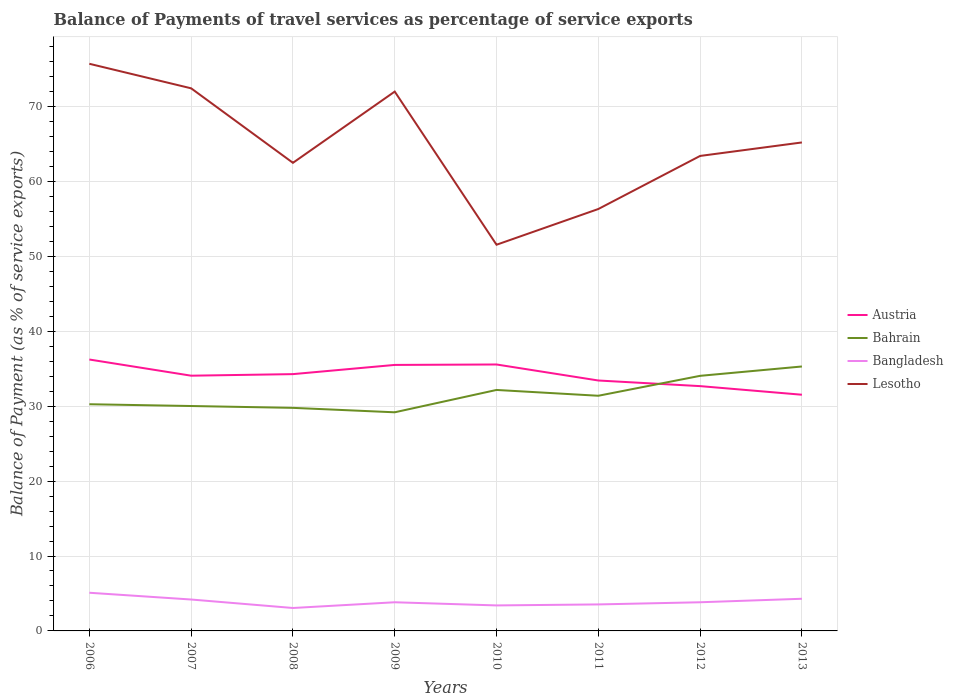Does the line corresponding to Bangladesh intersect with the line corresponding to Austria?
Provide a succinct answer. No. Across all years, what is the maximum balance of payments of travel services in Bangladesh?
Offer a terse response. 3.06. In which year was the balance of payments of travel services in Austria maximum?
Offer a terse response. 2013. What is the total balance of payments of travel services in Austria in the graph?
Your response must be concise. 0.75. What is the difference between the highest and the second highest balance of payments of travel services in Bangladesh?
Make the answer very short. 2.04. Is the balance of payments of travel services in Bahrain strictly greater than the balance of payments of travel services in Austria over the years?
Make the answer very short. No. What is the difference between two consecutive major ticks on the Y-axis?
Ensure brevity in your answer.  10. Does the graph contain any zero values?
Your answer should be compact. No. Where does the legend appear in the graph?
Ensure brevity in your answer.  Center right. How many legend labels are there?
Offer a terse response. 4. What is the title of the graph?
Ensure brevity in your answer.  Balance of Payments of travel services as percentage of service exports. Does "Afghanistan" appear as one of the legend labels in the graph?
Your answer should be compact. No. What is the label or title of the Y-axis?
Your answer should be compact. Balance of Payment (as % of service exports). What is the Balance of Payment (as % of service exports) of Austria in 2006?
Offer a very short reply. 36.23. What is the Balance of Payment (as % of service exports) in Bahrain in 2006?
Your response must be concise. 30.26. What is the Balance of Payment (as % of service exports) in Bangladesh in 2006?
Your answer should be very brief. 5.1. What is the Balance of Payment (as % of service exports) of Lesotho in 2006?
Provide a short and direct response. 75.71. What is the Balance of Payment (as % of service exports) in Austria in 2007?
Provide a short and direct response. 34.07. What is the Balance of Payment (as % of service exports) in Bahrain in 2007?
Make the answer very short. 30.02. What is the Balance of Payment (as % of service exports) in Bangladesh in 2007?
Provide a short and direct response. 4.19. What is the Balance of Payment (as % of service exports) in Lesotho in 2007?
Offer a terse response. 72.43. What is the Balance of Payment (as % of service exports) in Austria in 2008?
Offer a very short reply. 34.28. What is the Balance of Payment (as % of service exports) in Bahrain in 2008?
Give a very brief answer. 29.78. What is the Balance of Payment (as % of service exports) of Bangladesh in 2008?
Your answer should be compact. 3.06. What is the Balance of Payment (as % of service exports) in Lesotho in 2008?
Offer a very short reply. 62.48. What is the Balance of Payment (as % of service exports) of Austria in 2009?
Your answer should be compact. 35.51. What is the Balance of Payment (as % of service exports) in Bahrain in 2009?
Offer a terse response. 29.18. What is the Balance of Payment (as % of service exports) of Bangladesh in 2009?
Provide a succinct answer. 3.83. What is the Balance of Payment (as % of service exports) in Lesotho in 2009?
Give a very brief answer. 71.99. What is the Balance of Payment (as % of service exports) of Austria in 2010?
Offer a terse response. 35.57. What is the Balance of Payment (as % of service exports) of Bahrain in 2010?
Offer a very short reply. 32.17. What is the Balance of Payment (as % of service exports) in Bangladesh in 2010?
Make the answer very short. 3.4. What is the Balance of Payment (as % of service exports) in Lesotho in 2010?
Ensure brevity in your answer.  51.55. What is the Balance of Payment (as % of service exports) of Austria in 2011?
Your answer should be compact. 33.43. What is the Balance of Payment (as % of service exports) in Bahrain in 2011?
Provide a succinct answer. 31.39. What is the Balance of Payment (as % of service exports) in Bangladesh in 2011?
Offer a very short reply. 3.54. What is the Balance of Payment (as % of service exports) in Lesotho in 2011?
Offer a terse response. 56.32. What is the Balance of Payment (as % of service exports) of Austria in 2012?
Your response must be concise. 32.68. What is the Balance of Payment (as % of service exports) in Bahrain in 2012?
Your response must be concise. 34.05. What is the Balance of Payment (as % of service exports) in Bangladesh in 2012?
Your answer should be very brief. 3.83. What is the Balance of Payment (as % of service exports) of Lesotho in 2012?
Your answer should be compact. 63.41. What is the Balance of Payment (as % of service exports) in Austria in 2013?
Make the answer very short. 31.53. What is the Balance of Payment (as % of service exports) of Bahrain in 2013?
Ensure brevity in your answer.  35.3. What is the Balance of Payment (as % of service exports) in Bangladesh in 2013?
Keep it short and to the point. 4.29. What is the Balance of Payment (as % of service exports) of Lesotho in 2013?
Make the answer very short. 65.21. Across all years, what is the maximum Balance of Payment (as % of service exports) in Austria?
Ensure brevity in your answer.  36.23. Across all years, what is the maximum Balance of Payment (as % of service exports) in Bahrain?
Your answer should be compact. 35.3. Across all years, what is the maximum Balance of Payment (as % of service exports) of Bangladesh?
Your answer should be compact. 5.1. Across all years, what is the maximum Balance of Payment (as % of service exports) in Lesotho?
Your response must be concise. 75.71. Across all years, what is the minimum Balance of Payment (as % of service exports) in Austria?
Offer a terse response. 31.53. Across all years, what is the minimum Balance of Payment (as % of service exports) in Bahrain?
Keep it short and to the point. 29.18. Across all years, what is the minimum Balance of Payment (as % of service exports) in Bangladesh?
Ensure brevity in your answer.  3.06. Across all years, what is the minimum Balance of Payment (as % of service exports) of Lesotho?
Provide a succinct answer. 51.55. What is the total Balance of Payment (as % of service exports) of Austria in the graph?
Provide a succinct answer. 273.28. What is the total Balance of Payment (as % of service exports) of Bahrain in the graph?
Offer a terse response. 252.15. What is the total Balance of Payment (as % of service exports) of Bangladesh in the graph?
Provide a short and direct response. 31.23. What is the total Balance of Payment (as % of service exports) of Lesotho in the graph?
Your response must be concise. 519.1. What is the difference between the Balance of Payment (as % of service exports) of Austria in 2006 and that in 2007?
Offer a very short reply. 2.16. What is the difference between the Balance of Payment (as % of service exports) of Bahrain in 2006 and that in 2007?
Ensure brevity in your answer.  0.24. What is the difference between the Balance of Payment (as % of service exports) in Bangladesh in 2006 and that in 2007?
Your answer should be compact. 0.9. What is the difference between the Balance of Payment (as % of service exports) of Lesotho in 2006 and that in 2007?
Offer a terse response. 3.27. What is the difference between the Balance of Payment (as % of service exports) in Austria in 2006 and that in 2008?
Provide a succinct answer. 1.95. What is the difference between the Balance of Payment (as % of service exports) of Bahrain in 2006 and that in 2008?
Keep it short and to the point. 0.48. What is the difference between the Balance of Payment (as % of service exports) of Bangladesh in 2006 and that in 2008?
Provide a short and direct response. 2.04. What is the difference between the Balance of Payment (as % of service exports) in Lesotho in 2006 and that in 2008?
Provide a succinct answer. 13.22. What is the difference between the Balance of Payment (as % of service exports) of Austria in 2006 and that in 2009?
Offer a terse response. 0.72. What is the difference between the Balance of Payment (as % of service exports) of Bahrain in 2006 and that in 2009?
Provide a succinct answer. 1.08. What is the difference between the Balance of Payment (as % of service exports) in Bangladesh in 2006 and that in 2009?
Make the answer very short. 1.27. What is the difference between the Balance of Payment (as % of service exports) in Lesotho in 2006 and that in 2009?
Keep it short and to the point. 3.71. What is the difference between the Balance of Payment (as % of service exports) in Austria in 2006 and that in 2010?
Your answer should be compact. 0.66. What is the difference between the Balance of Payment (as % of service exports) of Bahrain in 2006 and that in 2010?
Offer a very short reply. -1.91. What is the difference between the Balance of Payment (as % of service exports) of Bangladesh in 2006 and that in 2010?
Offer a very short reply. 1.69. What is the difference between the Balance of Payment (as % of service exports) in Lesotho in 2006 and that in 2010?
Provide a succinct answer. 24.15. What is the difference between the Balance of Payment (as % of service exports) of Austria in 2006 and that in 2011?
Your answer should be very brief. 2.8. What is the difference between the Balance of Payment (as % of service exports) of Bahrain in 2006 and that in 2011?
Your answer should be very brief. -1.13. What is the difference between the Balance of Payment (as % of service exports) of Bangladesh in 2006 and that in 2011?
Give a very brief answer. 1.56. What is the difference between the Balance of Payment (as % of service exports) in Lesotho in 2006 and that in 2011?
Keep it short and to the point. 19.39. What is the difference between the Balance of Payment (as % of service exports) of Austria in 2006 and that in 2012?
Offer a very short reply. 3.55. What is the difference between the Balance of Payment (as % of service exports) of Bahrain in 2006 and that in 2012?
Provide a short and direct response. -3.79. What is the difference between the Balance of Payment (as % of service exports) in Bangladesh in 2006 and that in 2012?
Provide a succinct answer. 1.27. What is the difference between the Balance of Payment (as % of service exports) of Lesotho in 2006 and that in 2012?
Give a very brief answer. 12.3. What is the difference between the Balance of Payment (as % of service exports) in Austria in 2006 and that in 2013?
Your response must be concise. 4.7. What is the difference between the Balance of Payment (as % of service exports) of Bahrain in 2006 and that in 2013?
Ensure brevity in your answer.  -5.04. What is the difference between the Balance of Payment (as % of service exports) in Bangladesh in 2006 and that in 2013?
Provide a succinct answer. 0.8. What is the difference between the Balance of Payment (as % of service exports) of Lesotho in 2006 and that in 2013?
Ensure brevity in your answer.  10.5. What is the difference between the Balance of Payment (as % of service exports) of Austria in 2007 and that in 2008?
Your answer should be compact. -0.21. What is the difference between the Balance of Payment (as % of service exports) of Bahrain in 2007 and that in 2008?
Provide a succinct answer. 0.25. What is the difference between the Balance of Payment (as % of service exports) in Bangladesh in 2007 and that in 2008?
Ensure brevity in your answer.  1.13. What is the difference between the Balance of Payment (as % of service exports) in Lesotho in 2007 and that in 2008?
Your answer should be compact. 9.95. What is the difference between the Balance of Payment (as % of service exports) in Austria in 2007 and that in 2009?
Your response must be concise. -1.44. What is the difference between the Balance of Payment (as % of service exports) in Bahrain in 2007 and that in 2009?
Give a very brief answer. 0.84. What is the difference between the Balance of Payment (as % of service exports) of Bangladesh in 2007 and that in 2009?
Provide a short and direct response. 0.37. What is the difference between the Balance of Payment (as % of service exports) of Lesotho in 2007 and that in 2009?
Offer a very short reply. 0.44. What is the difference between the Balance of Payment (as % of service exports) of Austria in 2007 and that in 2010?
Provide a succinct answer. -1.5. What is the difference between the Balance of Payment (as % of service exports) of Bahrain in 2007 and that in 2010?
Ensure brevity in your answer.  -2.15. What is the difference between the Balance of Payment (as % of service exports) in Bangladesh in 2007 and that in 2010?
Your response must be concise. 0.79. What is the difference between the Balance of Payment (as % of service exports) in Lesotho in 2007 and that in 2010?
Ensure brevity in your answer.  20.88. What is the difference between the Balance of Payment (as % of service exports) of Austria in 2007 and that in 2011?
Keep it short and to the point. 0.64. What is the difference between the Balance of Payment (as % of service exports) in Bahrain in 2007 and that in 2011?
Ensure brevity in your answer.  -1.37. What is the difference between the Balance of Payment (as % of service exports) in Bangladesh in 2007 and that in 2011?
Make the answer very short. 0.66. What is the difference between the Balance of Payment (as % of service exports) in Lesotho in 2007 and that in 2011?
Your answer should be very brief. 16.11. What is the difference between the Balance of Payment (as % of service exports) in Austria in 2007 and that in 2012?
Keep it short and to the point. 1.39. What is the difference between the Balance of Payment (as % of service exports) of Bahrain in 2007 and that in 2012?
Offer a very short reply. -4.03. What is the difference between the Balance of Payment (as % of service exports) of Bangladesh in 2007 and that in 2012?
Your response must be concise. 0.37. What is the difference between the Balance of Payment (as % of service exports) of Lesotho in 2007 and that in 2012?
Offer a terse response. 9.03. What is the difference between the Balance of Payment (as % of service exports) in Austria in 2007 and that in 2013?
Ensure brevity in your answer.  2.54. What is the difference between the Balance of Payment (as % of service exports) in Bahrain in 2007 and that in 2013?
Your answer should be very brief. -5.28. What is the difference between the Balance of Payment (as % of service exports) in Bangladesh in 2007 and that in 2013?
Give a very brief answer. -0.1. What is the difference between the Balance of Payment (as % of service exports) of Lesotho in 2007 and that in 2013?
Your answer should be very brief. 7.23. What is the difference between the Balance of Payment (as % of service exports) of Austria in 2008 and that in 2009?
Ensure brevity in your answer.  -1.23. What is the difference between the Balance of Payment (as % of service exports) of Bahrain in 2008 and that in 2009?
Keep it short and to the point. 0.59. What is the difference between the Balance of Payment (as % of service exports) in Bangladesh in 2008 and that in 2009?
Offer a very short reply. -0.77. What is the difference between the Balance of Payment (as % of service exports) in Lesotho in 2008 and that in 2009?
Provide a short and direct response. -9.51. What is the difference between the Balance of Payment (as % of service exports) of Austria in 2008 and that in 2010?
Your answer should be very brief. -1.29. What is the difference between the Balance of Payment (as % of service exports) of Bahrain in 2008 and that in 2010?
Your answer should be compact. -2.39. What is the difference between the Balance of Payment (as % of service exports) of Bangladesh in 2008 and that in 2010?
Your answer should be very brief. -0.34. What is the difference between the Balance of Payment (as % of service exports) in Lesotho in 2008 and that in 2010?
Provide a succinct answer. 10.93. What is the difference between the Balance of Payment (as % of service exports) of Austria in 2008 and that in 2011?
Keep it short and to the point. 0.85. What is the difference between the Balance of Payment (as % of service exports) in Bahrain in 2008 and that in 2011?
Ensure brevity in your answer.  -1.61. What is the difference between the Balance of Payment (as % of service exports) of Bangladesh in 2008 and that in 2011?
Keep it short and to the point. -0.48. What is the difference between the Balance of Payment (as % of service exports) in Lesotho in 2008 and that in 2011?
Offer a terse response. 6.16. What is the difference between the Balance of Payment (as % of service exports) in Austria in 2008 and that in 2012?
Offer a very short reply. 1.6. What is the difference between the Balance of Payment (as % of service exports) of Bahrain in 2008 and that in 2012?
Ensure brevity in your answer.  -4.28. What is the difference between the Balance of Payment (as % of service exports) of Bangladesh in 2008 and that in 2012?
Ensure brevity in your answer.  -0.77. What is the difference between the Balance of Payment (as % of service exports) in Lesotho in 2008 and that in 2012?
Your answer should be compact. -0.92. What is the difference between the Balance of Payment (as % of service exports) in Austria in 2008 and that in 2013?
Keep it short and to the point. 2.75. What is the difference between the Balance of Payment (as % of service exports) of Bahrain in 2008 and that in 2013?
Your answer should be very brief. -5.52. What is the difference between the Balance of Payment (as % of service exports) of Bangladesh in 2008 and that in 2013?
Offer a very short reply. -1.23. What is the difference between the Balance of Payment (as % of service exports) of Lesotho in 2008 and that in 2013?
Your response must be concise. -2.72. What is the difference between the Balance of Payment (as % of service exports) of Austria in 2009 and that in 2010?
Provide a succinct answer. -0.06. What is the difference between the Balance of Payment (as % of service exports) of Bahrain in 2009 and that in 2010?
Your response must be concise. -2.98. What is the difference between the Balance of Payment (as % of service exports) of Bangladesh in 2009 and that in 2010?
Keep it short and to the point. 0.42. What is the difference between the Balance of Payment (as % of service exports) of Lesotho in 2009 and that in 2010?
Your answer should be very brief. 20.44. What is the difference between the Balance of Payment (as % of service exports) of Austria in 2009 and that in 2011?
Make the answer very short. 2.08. What is the difference between the Balance of Payment (as % of service exports) of Bahrain in 2009 and that in 2011?
Provide a succinct answer. -2.21. What is the difference between the Balance of Payment (as % of service exports) in Bangladesh in 2009 and that in 2011?
Your response must be concise. 0.29. What is the difference between the Balance of Payment (as % of service exports) of Lesotho in 2009 and that in 2011?
Your answer should be very brief. 15.67. What is the difference between the Balance of Payment (as % of service exports) of Austria in 2009 and that in 2012?
Provide a short and direct response. 2.83. What is the difference between the Balance of Payment (as % of service exports) in Bahrain in 2009 and that in 2012?
Offer a very short reply. -4.87. What is the difference between the Balance of Payment (as % of service exports) in Bangladesh in 2009 and that in 2012?
Make the answer very short. -0. What is the difference between the Balance of Payment (as % of service exports) of Lesotho in 2009 and that in 2012?
Provide a succinct answer. 8.59. What is the difference between the Balance of Payment (as % of service exports) in Austria in 2009 and that in 2013?
Give a very brief answer. 3.98. What is the difference between the Balance of Payment (as % of service exports) in Bahrain in 2009 and that in 2013?
Provide a short and direct response. -6.11. What is the difference between the Balance of Payment (as % of service exports) in Bangladesh in 2009 and that in 2013?
Your response must be concise. -0.47. What is the difference between the Balance of Payment (as % of service exports) in Lesotho in 2009 and that in 2013?
Make the answer very short. 6.79. What is the difference between the Balance of Payment (as % of service exports) of Austria in 2010 and that in 2011?
Make the answer very short. 2.14. What is the difference between the Balance of Payment (as % of service exports) of Bahrain in 2010 and that in 2011?
Offer a very short reply. 0.78. What is the difference between the Balance of Payment (as % of service exports) in Bangladesh in 2010 and that in 2011?
Your answer should be very brief. -0.13. What is the difference between the Balance of Payment (as % of service exports) of Lesotho in 2010 and that in 2011?
Offer a terse response. -4.77. What is the difference between the Balance of Payment (as % of service exports) of Austria in 2010 and that in 2012?
Provide a succinct answer. 2.89. What is the difference between the Balance of Payment (as % of service exports) of Bahrain in 2010 and that in 2012?
Offer a terse response. -1.88. What is the difference between the Balance of Payment (as % of service exports) in Bangladesh in 2010 and that in 2012?
Keep it short and to the point. -0.42. What is the difference between the Balance of Payment (as % of service exports) in Lesotho in 2010 and that in 2012?
Make the answer very short. -11.85. What is the difference between the Balance of Payment (as % of service exports) in Austria in 2010 and that in 2013?
Provide a short and direct response. 4.04. What is the difference between the Balance of Payment (as % of service exports) of Bahrain in 2010 and that in 2013?
Make the answer very short. -3.13. What is the difference between the Balance of Payment (as % of service exports) in Bangladesh in 2010 and that in 2013?
Offer a very short reply. -0.89. What is the difference between the Balance of Payment (as % of service exports) in Lesotho in 2010 and that in 2013?
Make the answer very short. -13.65. What is the difference between the Balance of Payment (as % of service exports) of Austria in 2011 and that in 2012?
Offer a terse response. 0.75. What is the difference between the Balance of Payment (as % of service exports) in Bahrain in 2011 and that in 2012?
Give a very brief answer. -2.66. What is the difference between the Balance of Payment (as % of service exports) of Bangladesh in 2011 and that in 2012?
Ensure brevity in your answer.  -0.29. What is the difference between the Balance of Payment (as % of service exports) in Lesotho in 2011 and that in 2012?
Your answer should be compact. -7.08. What is the difference between the Balance of Payment (as % of service exports) of Austria in 2011 and that in 2013?
Your answer should be very brief. 1.9. What is the difference between the Balance of Payment (as % of service exports) of Bahrain in 2011 and that in 2013?
Make the answer very short. -3.91. What is the difference between the Balance of Payment (as % of service exports) of Bangladesh in 2011 and that in 2013?
Ensure brevity in your answer.  -0.75. What is the difference between the Balance of Payment (as % of service exports) in Lesotho in 2011 and that in 2013?
Make the answer very short. -8.88. What is the difference between the Balance of Payment (as % of service exports) in Austria in 2012 and that in 2013?
Your answer should be very brief. 1.15. What is the difference between the Balance of Payment (as % of service exports) of Bahrain in 2012 and that in 2013?
Provide a short and direct response. -1.25. What is the difference between the Balance of Payment (as % of service exports) of Bangladesh in 2012 and that in 2013?
Provide a succinct answer. -0.47. What is the difference between the Balance of Payment (as % of service exports) in Lesotho in 2012 and that in 2013?
Offer a terse response. -1.8. What is the difference between the Balance of Payment (as % of service exports) in Austria in 2006 and the Balance of Payment (as % of service exports) in Bahrain in 2007?
Your answer should be very brief. 6.21. What is the difference between the Balance of Payment (as % of service exports) of Austria in 2006 and the Balance of Payment (as % of service exports) of Bangladesh in 2007?
Offer a terse response. 32.04. What is the difference between the Balance of Payment (as % of service exports) of Austria in 2006 and the Balance of Payment (as % of service exports) of Lesotho in 2007?
Your answer should be very brief. -36.2. What is the difference between the Balance of Payment (as % of service exports) in Bahrain in 2006 and the Balance of Payment (as % of service exports) in Bangladesh in 2007?
Provide a succinct answer. 26.07. What is the difference between the Balance of Payment (as % of service exports) of Bahrain in 2006 and the Balance of Payment (as % of service exports) of Lesotho in 2007?
Provide a short and direct response. -42.17. What is the difference between the Balance of Payment (as % of service exports) of Bangladesh in 2006 and the Balance of Payment (as % of service exports) of Lesotho in 2007?
Offer a very short reply. -67.34. What is the difference between the Balance of Payment (as % of service exports) in Austria in 2006 and the Balance of Payment (as % of service exports) in Bahrain in 2008?
Your answer should be very brief. 6.45. What is the difference between the Balance of Payment (as % of service exports) in Austria in 2006 and the Balance of Payment (as % of service exports) in Bangladesh in 2008?
Make the answer very short. 33.17. What is the difference between the Balance of Payment (as % of service exports) of Austria in 2006 and the Balance of Payment (as % of service exports) of Lesotho in 2008?
Give a very brief answer. -26.26. What is the difference between the Balance of Payment (as % of service exports) in Bahrain in 2006 and the Balance of Payment (as % of service exports) in Bangladesh in 2008?
Offer a terse response. 27.2. What is the difference between the Balance of Payment (as % of service exports) in Bahrain in 2006 and the Balance of Payment (as % of service exports) in Lesotho in 2008?
Your response must be concise. -32.22. What is the difference between the Balance of Payment (as % of service exports) in Bangladesh in 2006 and the Balance of Payment (as % of service exports) in Lesotho in 2008?
Offer a very short reply. -57.39. What is the difference between the Balance of Payment (as % of service exports) in Austria in 2006 and the Balance of Payment (as % of service exports) in Bahrain in 2009?
Your answer should be compact. 7.05. What is the difference between the Balance of Payment (as % of service exports) in Austria in 2006 and the Balance of Payment (as % of service exports) in Bangladesh in 2009?
Keep it short and to the point. 32.4. What is the difference between the Balance of Payment (as % of service exports) in Austria in 2006 and the Balance of Payment (as % of service exports) in Lesotho in 2009?
Your response must be concise. -35.77. What is the difference between the Balance of Payment (as % of service exports) of Bahrain in 2006 and the Balance of Payment (as % of service exports) of Bangladesh in 2009?
Provide a short and direct response. 26.43. What is the difference between the Balance of Payment (as % of service exports) in Bahrain in 2006 and the Balance of Payment (as % of service exports) in Lesotho in 2009?
Offer a very short reply. -41.73. What is the difference between the Balance of Payment (as % of service exports) in Bangladesh in 2006 and the Balance of Payment (as % of service exports) in Lesotho in 2009?
Offer a very short reply. -66.9. What is the difference between the Balance of Payment (as % of service exports) in Austria in 2006 and the Balance of Payment (as % of service exports) in Bahrain in 2010?
Give a very brief answer. 4.06. What is the difference between the Balance of Payment (as % of service exports) of Austria in 2006 and the Balance of Payment (as % of service exports) of Bangladesh in 2010?
Keep it short and to the point. 32.82. What is the difference between the Balance of Payment (as % of service exports) in Austria in 2006 and the Balance of Payment (as % of service exports) in Lesotho in 2010?
Offer a very short reply. -15.32. What is the difference between the Balance of Payment (as % of service exports) in Bahrain in 2006 and the Balance of Payment (as % of service exports) in Bangladesh in 2010?
Provide a short and direct response. 26.86. What is the difference between the Balance of Payment (as % of service exports) in Bahrain in 2006 and the Balance of Payment (as % of service exports) in Lesotho in 2010?
Make the answer very short. -21.29. What is the difference between the Balance of Payment (as % of service exports) in Bangladesh in 2006 and the Balance of Payment (as % of service exports) in Lesotho in 2010?
Offer a terse response. -46.46. What is the difference between the Balance of Payment (as % of service exports) of Austria in 2006 and the Balance of Payment (as % of service exports) of Bahrain in 2011?
Provide a succinct answer. 4.84. What is the difference between the Balance of Payment (as % of service exports) in Austria in 2006 and the Balance of Payment (as % of service exports) in Bangladesh in 2011?
Offer a terse response. 32.69. What is the difference between the Balance of Payment (as % of service exports) in Austria in 2006 and the Balance of Payment (as % of service exports) in Lesotho in 2011?
Your answer should be very brief. -20.09. What is the difference between the Balance of Payment (as % of service exports) of Bahrain in 2006 and the Balance of Payment (as % of service exports) of Bangladesh in 2011?
Give a very brief answer. 26.72. What is the difference between the Balance of Payment (as % of service exports) in Bahrain in 2006 and the Balance of Payment (as % of service exports) in Lesotho in 2011?
Provide a short and direct response. -26.06. What is the difference between the Balance of Payment (as % of service exports) of Bangladesh in 2006 and the Balance of Payment (as % of service exports) of Lesotho in 2011?
Offer a terse response. -51.22. What is the difference between the Balance of Payment (as % of service exports) in Austria in 2006 and the Balance of Payment (as % of service exports) in Bahrain in 2012?
Provide a succinct answer. 2.18. What is the difference between the Balance of Payment (as % of service exports) of Austria in 2006 and the Balance of Payment (as % of service exports) of Bangladesh in 2012?
Your answer should be very brief. 32.4. What is the difference between the Balance of Payment (as % of service exports) of Austria in 2006 and the Balance of Payment (as % of service exports) of Lesotho in 2012?
Give a very brief answer. -27.18. What is the difference between the Balance of Payment (as % of service exports) in Bahrain in 2006 and the Balance of Payment (as % of service exports) in Bangladesh in 2012?
Your response must be concise. 26.43. What is the difference between the Balance of Payment (as % of service exports) in Bahrain in 2006 and the Balance of Payment (as % of service exports) in Lesotho in 2012?
Your answer should be very brief. -33.15. What is the difference between the Balance of Payment (as % of service exports) of Bangladesh in 2006 and the Balance of Payment (as % of service exports) of Lesotho in 2012?
Make the answer very short. -58.31. What is the difference between the Balance of Payment (as % of service exports) in Austria in 2006 and the Balance of Payment (as % of service exports) in Bahrain in 2013?
Make the answer very short. 0.93. What is the difference between the Balance of Payment (as % of service exports) in Austria in 2006 and the Balance of Payment (as % of service exports) in Bangladesh in 2013?
Your answer should be compact. 31.94. What is the difference between the Balance of Payment (as % of service exports) of Austria in 2006 and the Balance of Payment (as % of service exports) of Lesotho in 2013?
Offer a terse response. -28.98. What is the difference between the Balance of Payment (as % of service exports) in Bahrain in 2006 and the Balance of Payment (as % of service exports) in Bangladesh in 2013?
Your answer should be compact. 25.97. What is the difference between the Balance of Payment (as % of service exports) in Bahrain in 2006 and the Balance of Payment (as % of service exports) in Lesotho in 2013?
Provide a succinct answer. -34.94. What is the difference between the Balance of Payment (as % of service exports) of Bangladesh in 2006 and the Balance of Payment (as % of service exports) of Lesotho in 2013?
Your answer should be very brief. -60.11. What is the difference between the Balance of Payment (as % of service exports) of Austria in 2007 and the Balance of Payment (as % of service exports) of Bahrain in 2008?
Provide a succinct answer. 4.29. What is the difference between the Balance of Payment (as % of service exports) in Austria in 2007 and the Balance of Payment (as % of service exports) in Bangladesh in 2008?
Offer a very short reply. 31.01. What is the difference between the Balance of Payment (as % of service exports) of Austria in 2007 and the Balance of Payment (as % of service exports) of Lesotho in 2008?
Provide a succinct answer. -28.41. What is the difference between the Balance of Payment (as % of service exports) of Bahrain in 2007 and the Balance of Payment (as % of service exports) of Bangladesh in 2008?
Offer a terse response. 26.96. What is the difference between the Balance of Payment (as % of service exports) of Bahrain in 2007 and the Balance of Payment (as % of service exports) of Lesotho in 2008?
Give a very brief answer. -32.46. What is the difference between the Balance of Payment (as % of service exports) of Bangladesh in 2007 and the Balance of Payment (as % of service exports) of Lesotho in 2008?
Your answer should be compact. -58.29. What is the difference between the Balance of Payment (as % of service exports) of Austria in 2007 and the Balance of Payment (as % of service exports) of Bahrain in 2009?
Ensure brevity in your answer.  4.89. What is the difference between the Balance of Payment (as % of service exports) in Austria in 2007 and the Balance of Payment (as % of service exports) in Bangladesh in 2009?
Keep it short and to the point. 30.24. What is the difference between the Balance of Payment (as % of service exports) of Austria in 2007 and the Balance of Payment (as % of service exports) of Lesotho in 2009?
Your answer should be compact. -37.92. What is the difference between the Balance of Payment (as % of service exports) in Bahrain in 2007 and the Balance of Payment (as % of service exports) in Bangladesh in 2009?
Give a very brief answer. 26.2. What is the difference between the Balance of Payment (as % of service exports) of Bahrain in 2007 and the Balance of Payment (as % of service exports) of Lesotho in 2009?
Offer a very short reply. -41.97. What is the difference between the Balance of Payment (as % of service exports) in Bangladesh in 2007 and the Balance of Payment (as % of service exports) in Lesotho in 2009?
Offer a very short reply. -67.8. What is the difference between the Balance of Payment (as % of service exports) in Austria in 2007 and the Balance of Payment (as % of service exports) in Bahrain in 2010?
Ensure brevity in your answer.  1.9. What is the difference between the Balance of Payment (as % of service exports) of Austria in 2007 and the Balance of Payment (as % of service exports) of Bangladesh in 2010?
Make the answer very short. 30.67. What is the difference between the Balance of Payment (as % of service exports) in Austria in 2007 and the Balance of Payment (as % of service exports) in Lesotho in 2010?
Offer a very short reply. -17.48. What is the difference between the Balance of Payment (as % of service exports) of Bahrain in 2007 and the Balance of Payment (as % of service exports) of Bangladesh in 2010?
Provide a succinct answer. 26.62. What is the difference between the Balance of Payment (as % of service exports) of Bahrain in 2007 and the Balance of Payment (as % of service exports) of Lesotho in 2010?
Make the answer very short. -21.53. What is the difference between the Balance of Payment (as % of service exports) in Bangladesh in 2007 and the Balance of Payment (as % of service exports) in Lesotho in 2010?
Make the answer very short. -47.36. What is the difference between the Balance of Payment (as % of service exports) of Austria in 2007 and the Balance of Payment (as % of service exports) of Bahrain in 2011?
Your response must be concise. 2.68. What is the difference between the Balance of Payment (as % of service exports) of Austria in 2007 and the Balance of Payment (as % of service exports) of Bangladesh in 2011?
Offer a very short reply. 30.53. What is the difference between the Balance of Payment (as % of service exports) in Austria in 2007 and the Balance of Payment (as % of service exports) in Lesotho in 2011?
Your answer should be very brief. -22.25. What is the difference between the Balance of Payment (as % of service exports) in Bahrain in 2007 and the Balance of Payment (as % of service exports) in Bangladesh in 2011?
Ensure brevity in your answer.  26.48. What is the difference between the Balance of Payment (as % of service exports) of Bahrain in 2007 and the Balance of Payment (as % of service exports) of Lesotho in 2011?
Give a very brief answer. -26.3. What is the difference between the Balance of Payment (as % of service exports) in Bangladesh in 2007 and the Balance of Payment (as % of service exports) in Lesotho in 2011?
Offer a terse response. -52.13. What is the difference between the Balance of Payment (as % of service exports) of Austria in 2007 and the Balance of Payment (as % of service exports) of Bahrain in 2012?
Your response must be concise. 0.02. What is the difference between the Balance of Payment (as % of service exports) of Austria in 2007 and the Balance of Payment (as % of service exports) of Bangladesh in 2012?
Ensure brevity in your answer.  30.24. What is the difference between the Balance of Payment (as % of service exports) of Austria in 2007 and the Balance of Payment (as % of service exports) of Lesotho in 2012?
Offer a terse response. -29.34. What is the difference between the Balance of Payment (as % of service exports) in Bahrain in 2007 and the Balance of Payment (as % of service exports) in Bangladesh in 2012?
Ensure brevity in your answer.  26.2. What is the difference between the Balance of Payment (as % of service exports) in Bahrain in 2007 and the Balance of Payment (as % of service exports) in Lesotho in 2012?
Ensure brevity in your answer.  -33.38. What is the difference between the Balance of Payment (as % of service exports) in Bangladesh in 2007 and the Balance of Payment (as % of service exports) in Lesotho in 2012?
Your answer should be very brief. -59.21. What is the difference between the Balance of Payment (as % of service exports) in Austria in 2007 and the Balance of Payment (as % of service exports) in Bahrain in 2013?
Offer a very short reply. -1.23. What is the difference between the Balance of Payment (as % of service exports) in Austria in 2007 and the Balance of Payment (as % of service exports) in Bangladesh in 2013?
Offer a very short reply. 29.78. What is the difference between the Balance of Payment (as % of service exports) in Austria in 2007 and the Balance of Payment (as % of service exports) in Lesotho in 2013?
Provide a succinct answer. -31.14. What is the difference between the Balance of Payment (as % of service exports) of Bahrain in 2007 and the Balance of Payment (as % of service exports) of Bangladesh in 2013?
Ensure brevity in your answer.  25.73. What is the difference between the Balance of Payment (as % of service exports) of Bahrain in 2007 and the Balance of Payment (as % of service exports) of Lesotho in 2013?
Offer a very short reply. -35.18. What is the difference between the Balance of Payment (as % of service exports) of Bangladesh in 2007 and the Balance of Payment (as % of service exports) of Lesotho in 2013?
Your answer should be very brief. -61.01. What is the difference between the Balance of Payment (as % of service exports) of Austria in 2008 and the Balance of Payment (as % of service exports) of Bahrain in 2009?
Make the answer very short. 5.09. What is the difference between the Balance of Payment (as % of service exports) in Austria in 2008 and the Balance of Payment (as % of service exports) in Bangladesh in 2009?
Provide a short and direct response. 30.45. What is the difference between the Balance of Payment (as % of service exports) of Austria in 2008 and the Balance of Payment (as % of service exports) of Lesotho in 2009?
Your response must be concise. -37.72. What is the difference between the Balance of Payment (as % of service exports) of Bahrain in 2008 and the Balance of Payment (as % of service exports) of Bangladesh in 2009?
Keep it short and to the point. 25.95. What is the difference between the Balance of Payment (as % of service exports) of Bahrain in 2008 and the Balance of Payment (as % of service exports) of Lesotho in 2009?
Provide a short and direct response. -42.22. What is the difference between the Balance of Payment (as % of service exports) in Bangladesh in 2008 and the Balance of Payment (as % of service exports) in Lesotho in 2009?
Offer a very short reply. -68.93. What is the difference between the Balance of Payment (as % of service exports) in Austria in 2008 and the Balance of Payment (as % of service exports) in Bahrain in 2010?
Your response must be concise. 2.11. What is the difference between the Balance of Payment (as % of service exports) in Austria in 2008 and the Balance of Payment (as % of service exports) in Bangladesh in 2010?
Your answer should be very brief. 30.87. What is the difference between the Balance of Payment (as % of service exports) of Austria in 2008 and the Balance of Payment (as % of service exports) of Lesotho in 2010?
Offer a very short reply. -17.27. What is the difference between the Balance of Payment (as % of service exports) in Bahrain in 2008 and the Balance of Payment (as % of service exports) in Bangladesh in 2010?
Provide a succinct answer. 26.37. What is the difference between the Balance of Payment (as % of service exports) in Bahrain in 2008 and the Balance of Payment (as % of service exports) in Lesotho in 2010?
Give a very brief answer. -21.77. What is the difference between the Balance of Payment (as % of service exports) of Bangladesh in 2008 and the Balance of Payment (as % of service exports) of Lesotho in 2010?
Provide a short and direct response. -48.49. What is the difference between the Balance of Payment (as % of service exports) in Austria in 2008 and the Balance of Payment (as % of service exports) in Bahrain in 2011?
Provide a short and direct response. 2.89. What is the difference between the Balance of Payment (as % of service exports) in Austria in 2008 and the Balance of Payment (as % of service exports) in Bangladesh in 2011?
Your answer should be compact. 30.74. What is the difference between the Balance of Payment (as % of service exports) of Austria in 2008 and the Balance of Payment (as % of service exports) of Lesotho in 2011?
Give a very brief answer. -22.04. What is the difference between the Balance of Payment (as % of service exports) of Bahrain in 2008 and the Balance of Payment (as % of service exports) of Bangladesh in 2011?
Your answer should be very brief. 26.24. What is the difference between the Balance of Payment (as % of service exports) of Bahrain in 2008 and the Balance of Payment (as % of service exports) of Lesotho in 2011?
Keep it short and to the point. -26.54. What is the difference between the Balance of Payment (as % of service exports) of Bangladesh in 2008 and the Balance of Payment (as % of service exports) of Lesotho in 2011?
Provide a succinct answer. -53.26. What is the difference between the Balance of Payment (as % of service exports) of Austria in 2008 and the Balance of Payment (as % of service exports) of Bahrain in 2012?
Offer a terse response. 0.23. What is the difference between the Balance of Payment (as % of service exports) in Austria in 2008 and the Balance of Payment (as % of service exports) in Bangladesh in 2012?
Keep it short and to the point. 30.45. What is the difference between the Balance of Payment (as % of service exports) of Austria in 2008 and the Balance of Payment (as % of service exports) of Lesotho in 2012?
Provide a short and direct response. -29.13. What is the difference between the Balance of Payment (as % of service exports) in Bahrain in 2008 and the Balance of Payment (as % of service exports) in Bangladesh in 2012?
Offer a terse response. 25.95. What is the difference between the Balance of Payment (as % of service exports) of Bahrain in 2008 and the Balance of Payment (as % of service exports) of Lesotho in 2012?
Provide a succinct answer. -33.63. What is the difference between the Balance of Payment (as % of service exports) of Bangladesh in 2008 and the Balance of Payment (as % of service exports) of Lesotho in 2012?
Offer a terse response. -60.34. What is the difference between the Balance of Payment (as % of service exports) in Austria in 2008 and the Balance of Payment (as % of service exports) in Bahrain in 2013?
Provide a short and direct response. -1.02. What is the difference between the Balance of Payment (as % of service exports) in Austria in 2008 and the Balance of Payment (as % of service exports) in Bangladesh in 2013?
Give a very brief answer. 29.99. What is the difference between the Balance of Payment (as % of service exports) in Austria in 2008 and the Balance of Payment (as % of service exports) in Lesotho in 2013?
Your response must be concise. -30.93. What is the difference between the Balance of Payment (as % of service exports) of Bahrain in 2008 and the Balance of Payment (as % of service exports) of Bangladesh in 2013?
Provide a succinct answer. 25.49. What is the difference between the Balance of Payment (as % of service exports) in Bahrain in 2008 and the Balance of Payment (as % of service exports) in Lesotho in 2013?
Make the answer very short. -35.43. What is the difference between the Balance of Payment (as % of service exports) in Bangladesh in 2008 and the Balance of Payment (as % of service exports) in Lesotho in 2013?
Ensure brevity in your answer.  -62.14. What is the difference between the Balance of Payment (as % of service exports) in Austria in 2009 and the Balance of Payment (as % of service exports) in Bahrain in 2010?
Give a very brief answer. 3.34. What is the difference between the Balance of Payment (as % of service exports) of Austria in 2009 and the Balance of Payment (as % of service exports) of Bangladesh in 2010?
Offer a terse response. 32.1. What is the difference between the Balance of Payment (as % of service exports) of Austria in 2009 and the Balance of Payment (as % of service exports) of Lesotho in 2010?
Offer a terse response. -16.04. What is the difference between the Balance of Payment (as % of service exports) of Bahrain in 2009 and the Balance of Payment (as % of service exports) of Bangladesh in 2010?
Keep it short and to the point. 25.78. What is the difference between the Balance of Payment (as % of service exports) in Bahrain in 2009 and the Balance of Payment (as % of service exports) in Lesotho in 2010?
Your answer should be compact. -22.37. What is the difference between the Balance of Payment (as % of service exports) in Bangladesh in 2009 and the Balance of Payment (as % of service exports) in Lesotho in 2010?
Ensure brevity in your answer.  -47.73. What is the difference between the Balance of Payment (as % of service exports) of Austria in 2009 and the Balance of Payment (as % of service exports) of Bahrain in 2011?
Offer a terse response. 4.12. What is the difference between the Balance of Payment (as % of service exports) of Austria in 2009 and the Balance of Payment (as % of service exports) of Bangladesh in 2011?
Your answer should be compact. 31.97. What is the difference between the Balance of Payment (as % of service exports) of Austria in 2009 and the Balance of Payment (as % of service exports) of Lesotho in 2011?
Keep it short and to the point. -20.81. What is the difference between the Balance of Payment (as % of service exports) in Bahrain in 2009 and the Balance of Payment (as % of service exports) in Bangladesh in 2011?
Provide a succinct answer. 25.65. What is the difference between the Balance of Payment (as % of service exports) in Bahrain in 2009 and the Balance of Payment (as % of service exports) in Lesotho in 2011?
Your answer should be very brief. -27.14. What is the difference between the Balance of Payment (as % of service exports) in Bangladesh in 2009 and the Balance of Payment (as % of service exports) in Lesotho in 2011?
Your response must be concise. -52.49. What is the difference between the Balance of Payment (as % of service exports) in Austria in 2009 and the Balance of Payment (as % of service exports) in Bahrain in 2012?
Provide a short and direct response. 1.46. What is the difference between the Balance of Payment (as % of service exports) in Austria in 2009 and the Balance of Payment (as % of service exports) in Bangladesh in 2012?
Your answer should be very brief. 31.68. What is the difference between the Balance of Payment (as % of service exports) in Austria in 2009 and the Balance of Payment (as % of service exports) in Lesotho in 2012?
Make the answer very short. -27.9. What is the difference between the Balance of Payment (as % of service exports) in Bahrain in 2009 and the Balance of Payment (as % of service exports) in Bangladesh in 2012?
Ensure brevity in your answer.  25.36. What is the difference between the Balance of Payment (as % of service exports) of Bahrain in 2009 and the Balance of Payment (as % of service exports) of Lesotho in 2012?
Keep it short and to the point. -34.22. What is the difference between the Balance of Payment (as % of service exports) in Bangladesh in 2009 and the Balance of Payment (as % of service exports) in Lesotho in 2012?
Offer a terse response. -59.58. What is the difference between the Balance of Payment (as % of service exports) in Austria in 2009 and the Balance of Payment (as % of service exports) in Bahrain in 2013?
Offer a terse response. 0.21. What is the difference between the Balance of Payment (as % of service exports) of Austria in 2009 and the Balance of Payment (as % of service exports) of Bangladesh in 2013?
Offer a terse response. 31.22. What is the difference between the Balance of Payment (as % of service exports) in Austria in 2009 and the Balance of Payment (as % of service exports) in Lesotho in 2013?
Your answer should be very brief. -29.7. What is the difference between the Balance of Payment (as % of service exports) in Bahrain in 2009 and the Balance of Payment (as % of service exports) in Bangladesh in 2013?
Make the answer very short. 24.89. What is the difference between the Balance of Payment (as % of service exports) in Bahrain in 2009 and the Balance of Payment (as % of service exports) in Lesotho in 2013?
Offer a very short reply. -36.02. What is the difference between the Balance of Payment (as % of service exports) of Bangladesh in 2009 and the Balance of Payment (as % of service exports) of Lesotho in 2013?
Give a very brief answer. -61.38. What is the difference between the Balance of Payment (as % of service exports) of Austria in 2010 and the Balance of Payment (as % of service exports) of Bahrain in 2011?
Your response must be concise. 4.17. What is the difference between the Balance of Payment (as % of service exports) in Austria in 2010 and the Balance of Payment (as % of service exports) in Bangladesh in 2011?
Offer a very short reply. 32.03. What is the difference between the Balance of Payment (as % of service exports) in Austria in 2010 and the Balance of Payment (as % of service exports) in Lesotho in 2011?
Your answer should be compact. -20.75. What is the difference between the Balance of Payment (as % of service exports) in Bahrain in 2010 and the Balance of Payment (as % of service exports) in Bangladesh in 2011?
Keep it short and to the point. 28.63. What is the difference between the Balance of Payment (as % of service exports) of Bahrain in 2010 and the Balance of Payment (as % of service exports) of Lesotho in 2011?
Make the answer very short. -24.15. What is the difference between the Balance of Payment (as % of service exports) in Bangladesh in 2010 and the Balance of Payment (as % of service exports) in Lesotho in 2011?
Provide a succinct answer. -52.92. What is the difference between the Balance of Payment (as % of service exports) in Austria in 2010 and the Balance of Payment (as % of service exports) in Bahrain in 2012?
Your answer should be compact. 1.51. What is the difference between the Balance of Payment (as % of service exports) of Austria in 2010 and the Balance of Payment (as % of service exports) of Bangladesh in 2012?
Your answer should be very brief. 31.74. What is the difference between the Balance of Payment (as % of service exports) of Austria in 2010 and the Balance of Payment (as % of service exports) of Lesotho in 2012?
Your response must be concise. -27.84. What is the difference between the Balance of Payment (as % of service exports) of Bahrain in 2010 and the Balance of Payment (as % of service exports) of Bangladesh in 2012?
Ensure brevity in your answer.  28.34. What is the difference between the Balance of Payment (as % of service exports) in Bahrain in 2010 and the Balance of Payment (as % of service exports) in Lesotho in 2012?
Make the answer very short. -31.24. What is the difference between the Balance of Payment (as % of service exports) in Bangladesh in 2010 and the Balance of Payment (as % of service exports) in Lesotho in 2012?
Provide a short and direct response. -60. What is the difference between the Balance of Payment (as % of service exports) in Austria in 2010 and the Balance of Payment (as % of service exports) in Bahrain in 2013?
Offer a very short reply. 0.27. What is the difference between the Balance of Payment (as % of service exports) of Austria in 2010 and the Balance of Payment (as % of service exports) of Bangladesh in 2013?
Provide a succinct answer. 31.27. What is the difference between the Balance of Payment (as % of service exports) of Austria in 2010 and the Balance of Payment (as % of service exports) of Lesotho in 2013?
Your response must be concise. -29.64. What is the difference between the Balance of Payment (as % of service exports) of Bahrain in 2010 and the Balance of Payment (as % of service exports) of Bangladesh in 2013?
Provide a short and direct response. 27.88. What is the difference between the Balance of Payment (as % of service exports) of Bahrain in 2010 and the Balance of Payment (as % of service exports) of Lesotho in 2013?
Provide a succinct answer. -33.04. What is the difference between the Balance of Payment (as % of service exports) in Bangladesh in 2010 and the Balance of Payment (as % of service exports) in Lesotho in 2013?
Provide a succinct answer. -61.8. What is the difference between the Balance of Payment (as % of service exports) in Austria in 2011 and the Balance of Payment (as % of service exports) in Bahrain in 2012?
Your response must be concise. -0.62. What is the difference between the Balance of Payment (as % of service exports) in Austria in 2011 and the Balance of Payment (as % of service exports) in Bangladesh in 2012?
Give a very brief answer. 29.6. What is the difference between the Balance of Payment (as % of service exports) in Austria in 2011 and the Balance of Payment (as % of service exports) in Lesotho in 2012?
Your response must be concise. -29.98. What is the difference between the Balance of Payment (as % of service exports) of Bahrain in 2011 and the Balance of Payment (as % of service exports) of Bangladesh in 2012?
Your answer should be compact. 27.57. What is the difference between the Balance of Payment (as % of service exports) of Bahrain in 2011 and the Balance of Payment (as % of service exports) of Lesotho in 2012?
Your answer should be compact. -32.01. What is the difference between the Balance of Payment (as % of service exports) of Bangladesh in 2011 and the Balance of Payment (as % of service exports) of Lesotho in 2012?
Ensure brevity in your answer.  -59.87. What is the difference between the Balance of Payment (as % of service exports) in Austria in 2011 and the Balance of Payment (as % of service exports) in Bahrain in 2013?
Ensure brevity in your answer.  -1.87. What is the difference between the Balance of Payment (as % of service exports) in Austria in 2011 and the Balance of Payment (as % of service exports) in Bangladesh in 2013?
Ensure brevity in your answer.  29.14. What is the difference between the Balance of Payment (as % of service exports) in Austria in 2011 and the Balance of Payment (as % of service exports) in Lesotho in 2013?
Provide a succinct answer. -31.78. What is the difference between the Balance of Payment (as % of service exports) of Bahrain in 2011 and the Balance of Payment (as % of service exports) of Bangladesh in 2013?
Ensure brevity in your answer.  27.1. What is the difference between the Balance of Payment (as % of service exports) of Bahrain in 2011 and the Balance of Payment (as % of service exports) of Lesotho in 2013?
Offer a very short reply. -33.81. What is the difference between the Balance of Payment (as % of service exports) in Bangladesh in 2011 and the Balance of Payment (as % of service exports) in Lesotho in 2013?
Provide a succinct answer. -61.67. What is the difference between the Balance of Payment (as % of service exports) of Austria in 2012 and the Balance of Payment (as % of service exports) of Bahrain in 2013?
Make the answer very short. -2.62. What is the difference between the Balance of Payment (as % of service exports) of Austria in 2012 and the Balance of Payment (as % of service exports) of Bangladesh in 2013?
Offer a terse response. 28.39. What is the difference between the Balance of Payment (as % of service exports) in Austria in 2012 and the Balance of Payment (as % of service exports) in Lesotho in 2013?
Provide a succinct answer. -32.53. What is the difference between the Balance of Payment (as % of service exports) of Bahrain in 2012 and the Balance of Payment (as % of service exports) of Bangladesh in 2013?
Keep it short and to the point. 29.76. What is the difference between the Balance of Payment (as % of service exports) of Bahrain in 2012 and the Balance of Payment (as % of service exports) of Lesotho in 2013?
Make the answer very short. -31.15. What is the difference between the Balance of Payment (as % of service exports) of Bangladesh in 2012 and the Balance of Payment (as % of service exports) of Lesotho in 2013?
Your response must be concise. -61.38. What is the average Balance of Payment (as % of service exports) of Austria per year?
Make the answer very short. 34.16. What is the average Balance of Payment (as % of service exports) of Bahrain per year?
Give a very brief answer. 31.52. What is the average Balance of Payment (as % of service exports) in Bangladesh per year?
Offer a terse response. 3.9. What is the average Balance of Payment (as % of service exports) of Lesotho per year?
Provide a short and direct response. 64.89. In the year 2006, what is the difference between the Balance of Payment (as % of service exports) of Austria and Balance of Payment (as % of service exports) of Bahrain?
Provide a succinct answer. 5.97. In the year 2006, what is the difference between the Balance of Payment (as % of service exports) in Austria and Balance of Payment (as % of service exports) in Bangladesh?
Give a very brief answer. 31.13. In the year 2006, what is the difference between the Balance of Payment (as % of service exports) in Austria and Balance of Payment (as % of service exports) in Lesotho?
Your answer should be compact. -39.48. In the year 2006, what is the difference between the Balance of Payment (as % of service exports) in Bahrain and Balance of Payment (as % of service exports) in Bangladesh?
Your answer should be very brief. 25.16. In the year 2006, what is the difference between the Balance of Payment (as % of service exports) in Bahrain and Balance of Payment (as % of service exports) in Lesotho?
Your answer should be compact. -45.44. In the year 2006, what is the difference between the Balance of Payment (as % of service exports) in Bangladesh and Balance of Payment (as % of service exports) in Lesotho?
Give a very brief answer. -70.61. In the year 2007, what is the difference between the Balance of Payment (as % of service exports) of Austria and Balance of Payment (as % of service exports) of Bahrain?
Make the answer very short. 4.05. In the year 2007, what is the difference between the Balance of Payment (as % of service exports) of Austria and Balance of Payment (as % of service exports) of Bangladesh?
Provide a succinct answer. 29.88. In the year 2007, what is the difference between the Balance of Payment (as % of service exports) of Austria and Balance of Payment (as % of service exports) of Lesotho?
Offer a very short reply. -38.36. In the year 2007, what is the difference between the Balance of Payment (as % of service exports) of Bahrain and Balance of Payment (as % of service exports) of Bangladesh?
Offer a very short reply. 25.83. In the year 2007, what is the difference between the Balance of Payment (as % of service exports) in Bahrain and Balance of Payment (as % of service exports) in Lesotho?
Your response must be concise. -42.41. In the year 2007, what is the difference between the Balance of Payment (as % of service exports) in Bangladesh and Balance of Payment (as % of service exports) in Lesotho?
Give a very brief answer. -68.24. In the year 2008, what is the difference between the Balance of Payment (as % of service exports) in Austria and Balance of Payment (as % of service exports) in Bahrain?
Make the answer very short. 4.5. In the year 2008, what is the difference between the Balance of Payment (as % of service exports) of Austria and Balance of Payment (as % of service exports) of Bangladesh?
Your answer should be very brief. 31.22. In the year 2008, what is the difference between the Balance of Payment (as % of service exports) in Austria and Balance of Payment (as % of service exports) in Lesotho?
Your response must be concise. -28.21. In the year 2008, what is the difference between the Balance of Payment (as % of service exports) of Bahrain and Balance of Payment (as % of service exports) of Bangladesh?
Keep it short and to the point. 26.72. In the year 2008, what is the difference between the Balance of Payment (as % of service exports) in Bahrain and Balance of Payment (as % of service exports) in Lesotho?
Offer a very short reply. -32.71. In the year 2008, what is the difference between the Balance of Payment (as % of service exports) in Bangladesh and Balance of Payment (as % of service exports) in Lesotho?
Keep it short and to the point. -59.42. In the year 2009, what is the difference between the Balance of Payment (as % of service exports) of Austria and Balance of Payment (as % of service exports) of Bahrain?
Ensure brevity in your answer.  6.32. In the year 2009, what is the difference between the Balance of Payment (as % of service exports) of Austria and Balance of Payment (as % of service exports) of Bangladesh?
Provide a succinct answer. 31.68. In the year 2009, what is the difference between the Balance of Payment (as % of service exports) of Austria and Balance of Payment (as % of service exports) of Lesotho?
Give a very brief answer. -36.49. In the year 2009, what is the difference between the Balance of Payment (as % of service exports) in Bahrain and Balance of Payment (as % of service exports) in Bangladesh?
Provide a short and direct response. 25.36. In the year 2009, what is the difference between the Balance of Payment (as % of service exports) in Bahrain and Balance of Payment (as % of service exports) in Lesotho?
Your answer should be compact. -42.81. In the year 2009, what is the difference between the Balance of Payment (as % of service exports) in Bangladesh and Balance of Payment (as % of service exports) in Lesotho?
Give a very brief answer. -68.17. In the year 2010, what is the difference between the Balance of Payment (as % of service exports) in Austria and Balance of Payment (as % of service exports) in Bahrain?
Give a very brief answer. 3.4. In the year 2010, what is the difference between the Balance of Payment (as % of service exports) of Austria and Balance of Payment (as % of service exports) of Bangladesh?
Keep it short and to the point. 32.16. In the year 2010, what is the difference between the Balance of Payment (as % of service exports) in Austria and Balance of Payment (as % of service exports) in Lesotho?
Your answer should be very brief. -15.99. In the year 2010, what is the difference between the Balance of Payment (as % of service exports) of Bahrain and Balance of Payment (as % of service exports) of Bangladesh?
Your response must be concise. 28.76. In the year 2010, what is the difference between the Balance of Payment (as % of service exports) of Bahrain and Balance of Payment (as % of service exports) of Lesotho?
Offer a very short reply. -19.38. In the year 2010, what is the difference between the Balance of Payment (as % of service exports) in Bangladesh and Balance of Payment (as % of service exports) in Lesotho?
Provide a succinct answer. -48.15. In the year 2011, what is the difference between the Balance of Payment (as % of service exports) in Austria and Balance of Payment (as % of service exports) in Bahrain?
Ensure brevity in your answer.  2.04. In the year 2011, what is the difference between the Balance of Payment (as % of service exports) in Austria and Balance of Payment (as % of service exports) in Bangladesh?
Offer a very short reply. 29.89. In the year 2011, what is the difference between the Balance of Payment (as % of service exports) in Austria and Balance of Payment (as % of service exports) in Lesotho?
Provide a succinct answer. -22.89. In the year 2011, what is the difference between the Balance of Payment (as % of service exports) of Bahrain and Balance of Payment (as % of service exports) of Bangladesh?
Provide a short and direct response. 27.85. In the year 2011, what is the difference between the Balance of Payment (as % of service exports) in Bahrain and Balance of Payment (as % of service exports) in Lesotho?
Your answer should be very brief. -24.93. In the year 2011, what is the difference between the Balance of Payment (as % of service exports) in Bangladesh and Balance of Payment (as % of service exports) in Lesotho?
Your response must be concise. -52.78. In the year 2012, what is the difference between the Balance of Payment (as % of service exports) of Austria and Balance of Payment (as % of service exports) of Bahrain?
Keep it short and to the point. -1.37. In the year 2012, what is the difference between the Balance of Payment (as % of service exports) of Austria and Balance of Payment (as % of service exports) of Bangladesh?
Ensure brevity in your answer.  28.85. In the year 2012, what is the difference between the Balance of Payment (as % of service exports) in Austria and Balance of Payment (as % of service exports) in Lesotho?
Keep it short and to the point. -30.73. In the year 2012, what is the difference between the Balance of Payment (as % of service exports) in Bahrain and Balance of Payment (as % of service exports) in Bangladesh?
Your answer should be compact. 30.23. In the year 2012, what is the difference between the Balance of Payment (as % of service exports) of Bahrain and Balance of Payment (as % of service exports) of Lesotho?
Make the answer very short. -29.35. In the year 2012, what is the difference between the Balance of Payment (as % of service exports) in Bangladesh and Balance of Payment (as % of service exports) in Lesotho?
Your response must be concise. -59.58. In the year 2013, what is the difference between the Balance of Payment (as % of service exports) in Austria and Balance of Payment (as % of service exports) in Bahrain?
Keep it short and to the point. -3.77. In the year 2013, what is the difference between the Balance of Payment (as % of service exports) of Austria and Balance of Payment (as % of service exports) of Bangladesh?
Your answer should be very brief. 27.24. In the year 2013, what is the difference between the Balance of Payment (as % of service exports) in Austria and Balance of Payment (as % of service exports) in Lesotho?
Make the answer very short. -33.68. In the year 2013, what is the difference between the Balance of Payment (as % of service exports) in Bahrain and Balance of Payment (as % of service exports) in Bangladesh?
Provide a succinct answer. 31.01. In the year 2013, what is the difference between the Balance of Payment (as % of service exports) in Bahrain and Balance of Payment (as % of service exports) in Lesotho?
Your answer should be very brief. -29.91. In the year 2013, what is the difference between the Balance of Payment (as % of service exports) of Bangladesh and Balance of Payment (as % of service exports) of Lesotho?
Your answer should be compact. -60.91. What is the ratio of the Balance of Payment (as % of service exports) of Austria in 2006 to that in 2007?
Your answer should be compact. 1.06. What is the ratio of the Balance of Payment (as % of service exports) in Bahrain in 2006 to that in 2007?
Your answer should be compact. 1.01. What is the ratio of the Balance of Payment (as % of service exports) of Bangladesh in 2006 to that in 2007?
Your response must be concise. 1.22. What is the ratio of the Balance of Payment (as % of service exports) of Lesotho in 2006 to that in 2007?
Your answer should be very brief. 1.05. What is the ratio of the Balance of Payment (as % of service exports) in Austria in 2006 to that in 2008?
Your response must be concise. 1.06. What is the ratio of the Balance of Payment (as % of service exports) of Bahrain in 2006 to that in 2008?
Your answer should be compact. 1.02. What is the ratio of the Balance of Payment (as % of service exports) in Bangladesh in 2006 to that in 2008?
Your response must be concise. 1.66. What is the ratio of the Balance of Payment (as % of service exports) in Lesotho in 2006 to that in 2008?
Your answer should be compact. 1.21. What is the ratio of the Balance of Payment (as % of service exports) in Austria in 2006 to that in 2009?
Offer a very short reply. 1.02. What is the ratio of the Balance of Payment (as % of service exports) of Bahrain in 2006 to that in 2009?
Your answer should be compact. 1.04. What is the ratio of the Balance of Payment (as % of service exports) of Bangladesh in 2006 to that in 2009?
Your response must be concise. 1.33. What is the ratio of the Balance of Payment (as % of service exports) of Lesotho in 2006 to that in 2009?
Offer a terse response. 1.05. What is the ratio of the Balance of Payment (as % of service exports) of Austria in 2006 to that in 2010?
Your response must be concise. 1.02. What is the ratio of the Balance of Payment (as % of service exports) of Bahrain in 2006 to that in 2010?
Your answer should be compact. 0.94. What is the ratio of the Balance of Payment (as % of service exports) in Bangladesh in 2006 to that in 2010?
Provide a short and direct response. 1.5. What is the ratio of the Balance of Payment (as % of service exports) of Lesotho in 2006 to that in 2010?
Keep it short and to the point. 1.47. What is the ratio of the Balance of Payment (as % of service exports) of Austria in 2006 to that in 2011?
Offer a very short reply. 1.08. What is the ratio of the Balance of Payment (as % of service exports) in Bangladesh in 2006 to that in 2011?
Ensure brevity in your answer.  1.44. What is the ratio of the Balance of Payment (as % of service exports) in Lesotho in 2006 to that in 2011?
Your answer should be compact. 1.34. What is the ratio of the Balance of Payment (as % of service exports) in Austria in 2006 to that in 2012?
Keep it short and to the point. 1.11. What is the ratio of the Balance of Payment (as % of service exports) in Bahrain in 2006 to that in 2012?
Keep it short and to the point. 0.89. What is the ratio of the Balance of Payment (as % of service exports) in Bangladesh in 2006 to that in 2012?
Ensure brevity in your answer.  1.33. What is the ratio of the Balance of Payment (as % of service exports) of Lesotho in 2006 to that in 2012?
Provide a short and direct response. 1.19. What is the ratio of the Balance of Payment (as % of service exports) of Austria in 2006 to that in 2013?
Provide a short and direct response. 1.15. What is the ratio of the Balance of Payment (as % of service exports) of Bahrain in 2006 to that in 2013?
Give a very brief answer. 0.86. What is the ratio of the Balance of Payment (as % of service exports) in Bangladesh in 2006 to that in 2013?
Provide a short and direct response. 1.19. What is the ratio of the Balance of Payment (as % of service exports) of Lesotho in 2006 to that in 2013?
Ensure brevity in your answer.  1.16. What is the ratio of the Balance of Payment (as % of service exports) in Bahrain in 2007 to that in 2008?
Keep it short and to the point. 1.01. What is the ratio of the Balance of Payment (as % of service exports) of Bangladesh in 2007 to that in 2008?
Offer a very short reply. 1.37. What is the ratio of the Balance of Payment (as % of service exports) of Lesotho in 2007 to that in 2008?
Give a very brief answer. 1.16. What is the ratio of the Balance of Payment (as % of service exports) of Austria in 2007 to that in 2009?
Your answer should be compact. 0.96. What is the ratio of the Balance of Payment (as % of service exports) in Bahrain in 2007 to that in 2009?
Your answer should be compact. 1.03. What is the ratio of the Balance of Payment (as % of service exports) of Bangladesh in 2007 to that in 2009?
Ensure brevity in your answer.  1.1. What is the ratio of the Balance of Payment (as % of service exports) in Austria in 2007 to that in 2010?
Ensure brevity in your answer.  0.96. What is the ratio of the Balance of Payment (as % of service exports) of Bangladesh in 2007 to that in 2010?
Provide a short and direct response. 1.23. What is the ratio of the Balance of Payment (as % of service exports) in Lesotho in 2007 to that in 2010?
Keep it short and to the point. 1.41. What is the ratio of the Balance of Payment (as % of service exports) of Austria in 2007 to that in 2011?
Keep it short and to the point. 1.02. What is the ratio of the Balance of Payment (as % of service exports) in Bahrain in 2007 to that in 2011?
Keep it short and to the point. 0.96. What is the ratio of the Balance of Payment (as % of service exports) of Bangladesh in 2007 to that in 2011?
Keep it short and to the point. 1.19. What is the ratio of the Balance of Payment (as % of service exports) of Lesotho in 2007 to that in 2011?
Ensure brevity in your answer.  1.29. What is the ratio of the Balance of Payment (as % of service exports) of Austria in 2007 to that in 2012?
Make the answer very short. 1.04. What is the ratio of the Balance of Payment (as % of service exports) in Bahrain in 2007 to that in 2012?
Make the answer very short. 0.88. What is the ratio of the Balance of Payment (as % of service exports) of Bangladesh in 2007 to that in 2012?
Your response must be concise. 1.1. What is the ratio of the Balance of Payment (as % of service exports) in Lesotho in 2007 to that in 2012?
Ensure brevity in your answer.  1.14. What is the ratio of the Balance of Payment (as % of service exports) in Austria in 2007 to that in 2013?
Ensure brevity in your answer.  1.08. What is the ratio of the Balance of Payment (as % of service exports) in Bahrain in 2007 to that in 2013?
Provide a succinct answer. 0.85. What is the ratio of the Balance of Payment (as % of service exports) of Bangladesh in 2007 to that in 2013?
Your answer should be very brief. 0.98. What is the ratio of the Balance of Payment (as % of service exports) of Lesotho in 2007 to that in 2013?
Provide a short and direct response. 1.11. What is the ratio of the Balance of Payment (as % of service exports) of Austria in 2008 to that in 2009?
Your answer should be compact. 0.97. What is the ratio of the Balance of Payment (as % of service exports) of Bahrain in 2008 to that in 2009?
Give a very brief answer. 1.02. What is the ratio of the Balance of Payment (as % of service exports) in Lesotho in 2008 to that in 2009?
Give a very brief answer. 0.87. What is the ratio of the Balance of Payment (as % of service exports) of Austria in 2008 to that in 2010?
Offer a terse response. 0.96. What is the ratio of the Balance of Payment (as % of service exports) in Bahrain in 2008 to that in 2010?
Offer a very short reply. 0.93. What is the ratio of the Balance of Payment (as % of service exports) of Bangladesh in 2008 to that in 2010?
Make the answer very short. 0.9. What is the ratio of the Balance of Payment (as % of service exports) of Lesotho in 2008 to that in 2010?
Your response must be concise. 1.21. What is the ratio of the Balance of Payment (as % of service exports) of Austria in 2008 to that in 2011?
Your response must be concise. 1.03. What is the ratio of the Balance of Payment (as % of service exports) of Bahrain in 2008 to that in 2011?
Make the answer very short. 0.95. What is the ratio of the Balance of Payment (as % of service exports) in Bangladesh in 2008 to that in 2011?
Your response must be concise. 0.87. What is the ratio of the Balance of Payment (as % of service exports) in Lesotho in 2008 to that in 2011?
Provide a succinct answer. 1.11. What is the ratio of the Balance of Payment (as % of service exports) of Austria in 2008 to that in 2012?
Ensure brevity in your answer.  1.05. What is the ratio of the Balance of Payment (as % of service exports) in Bahrain in 2008 to that in 2012?
Keep it short and to the point. 0.87. What is the ratio of the Balance of Payment (as % of service exports) in Bangladesh in 2008 to that in 2012?
Ensure brevity in your answer.  0.8. What is the ratio of the Balance of Payment (as % of service exports) in Lesotho in 2008 to that in 2012?
Offer a very short reply. 0.99. What is the ratio of the Balance of Payment (as % of service exports) of Austria in 2008 to that in 2013?
Give a very brief answer. 1.09. What is the ratio of the Balance of Payment (as % of service exports) of Bahrain in 2008 to that in 2013?
Ensure brevity in your answer.  0.84. What is the ratio of the Balance of Payment (as % of service exports) of Bangladesh in 2008 to that in 2013?
Offer a very short reply. 0.71. What is the ratio of the Balance of Payment (as % of service exports) of Bahrain in 2009 to that in 2010?
Give a very brief answer. 0.91. What is the ratio of the Balance of Payment (as % of service exports) of Bangladesh in 2009 to that in 2010?
Provide a succinct answer. 1.12. What is the ratio of the Balance of Payment (as % of service exports) of Lesotho in 2009 to that in 2010?
Offer a terse response. 1.4. What is the ratio of the Balance of Payment (as % of service exports) in Austria in 2009 to that in 2011?
Your answer should be very brief. 1.06. What is the ratio of the Balance of Payment (as % of service exports) of Bahrain in 2009 to that in 2011?
Ensure brevity in your answer.  0.93. What is the ratio of the Balance of Payment (as % of service exports) of Bangladesh in 2009 to that in 2011?
Your answer should be very brief. 1.08. What is the ratio of the Balance of Payment (as % of service exports) in Lesotho in 2009 to that in 2011?
Ensure brevity in your answer.  1.28. What is the ratio of the Balance of Payment (as % of service exports) of Austria in 2009 to that in 2012?
Make the answer very short. 1.09. What is the ratio of the Balance of Payment (as % of service exports) of Bahrain in 2009 to that in 2012?
Provide a succinct answer. 0.86. What is the ratio of the Balance of Payment (as % of service exports) of Lesotho in 2009 to that in 2012?
Give a very brief answer. 1.14. What is the ratio of the Balance of Payment (as % of service exports) in Austria in 2009 to that in 2013?
Offer a very short reply. 1.13. What is the ratio of the Balance of Payment (as % of service exports) in Bahrain in 2009 to that in 2013?
Your answer should be very brief. 0.83. What is the ratio of the Balance of Payment (as % of service exports) in Bangladesh in 2009 to that in 2013?
Provide a short and direct response. 0.89. What is the ratio of the Balance of Payment (as % of service exports) in Lesotho in 2009 to that in 2013?
Offer a terse response. 1.1. What is the ratio of the Balance of Payment (as % of service exports) in Austria in 2010 to that in 2011?
Your answer should be very brief. 1.06. What is the ratio of the Balance of Payment (as % of service exports) in Bahrain in 2010 to that in 2011?
Ensure brevity in your answer.  1.02. What is the ratio of the Balance of Payment (as % of service exports) in Bangladesh in 2010 to that in 2011?
Keep it short and to the point. 0.96. What is the ratio of the Balance of Payment (as % of service exports) of Lesotho in 2010 to that in 2011?
Offer a very short reply. 0.92. What is the ratio of the Balance of Payment (as % of service exports) in Austria in 2010 to that in 2012?
Offer a terse response. 1.09. What is the ratio of the Balance of Payment (as % of service exports) of Bahrain in 2010 to that in 2012?
Provide a succinct answer. 0.94. What is the ratio of the Balance of Payment (as % of service exports) in Bangladesh in 2010 to that in 2012?
Keep it short and to the point. 0.89. What is the ratio of the Balance of Payment (as % of service exports) of Lesotho in 2010 to that in 2012?
Offer a very short reply. 0.81. What is the ratio of the Balance of Payment (as % of service exports) in Austria in 2010 to that in 2013?
Make the answer very short. 1.13. What is the ratio of the Balance of Payment (as % of service exports) of Bahrain in 2010 to that in 2013?
Provide a short and direct response. 0.91. What is the ratio of the Balance of Payment (as % of service exports) in Bangladesh in 2010 to that in 2013?
Provide a short and direct response. 0.79. What is the ratio of the Balance of Payment (as % of service exports) in Lesotho in 2010 to that in 2013?
Offer a terse response. 0.79. What is the ratio of the Balance of Payment (as % of service exports) in Austria in 2011 to that in 2012?
Make the answer very short. 1.02. What is the ratio of the Balance of Payment (as % of service exports) in Bahrain in 2011 to that in 2012?
Give a very brief answer. 0.92. What is the ratio of the Balance of Payment (as % of service exports) in Bangladesh in 2011 to that in 2012?
Give a very brief answer. 0.92. What is the ratio of the Balance of Payment (as % of service exports) of Lesotho in 2011 to that in 2012?
Offer a very short reply. 0.89. What is the ratio of the Balance of Payment (as % of service exports) of Austria in 2011 to that in 2013?
Give a very brief answer. 1.06. What is the ratio of the Balance of Payment (as % of service exports) of Bahrain in 2011 to that in 2013?
Provide a succinct answer. 0.89. What is the ratio of the Balance of Payment (as % of service exports) of Bangladesh in 2011 to that in 2013?
Your answer should be very brief. 0.82. What is the ratio of the Balance of Payment (as % of service exports) of Lesotho in 2011 to that in 2013?
Your answer should be very brief. 0.86. What is the ratio of the Balance of Payment (as % of service exports) in Austria in 2012 to that in 2013?
Your response must be concise. 1.04. What is the ratio of the Balance of Payment (as % of service exports) in Bahrain in 2012 to that in 2013?
Make the answer very short. 0.96. What is the ratio of the Balance of Payment (as % of service exports) in Bangladesh in 2012 to that in 2013?
Your answer should be compact. 0.89. What is the ratio of the Balance of Payment (as % of service exports) of Lesotho in 2012 to that in 2013?
Offer a very short reply. 0.97. What is the difference between the highest and the second highest Balance of Payment (as % of service exports) in Austria?
Keep it short and to the point. 0.66. What is the difference between the highest and the second highest Balance of Payment (as % of service exports) of Bahrain?
Ensure brevity in your answer.  1.25. What is the difference between the highest and the second highest Balance of Payment (as % of service exports) in Bangladesh?
Provide a succinct answer. 0.8. What is the difference between the highest and the second highest Balance of Payment (as % of service exports) of Lesotho?
Offer a very short reply. 3.27. What is the difference between the highest and the lowest Balance of Payment (as % of service exports) in Austria?
Offer a terse response. 4.7. What is the difference between the highest and the lowest Balance of Payment (as % of service exports) of Bahrain?
Offer a terse response. 6.11. What is the difference between the highest and the lowest Balance of Payment (as % of service exports) in Bangladesh?
Offer a terse response. 2.04. What is the difference between the highest and the lowest Balance of Payment (as % of service exports) of Lesotho?
Your answer should be compact. 24.15. 